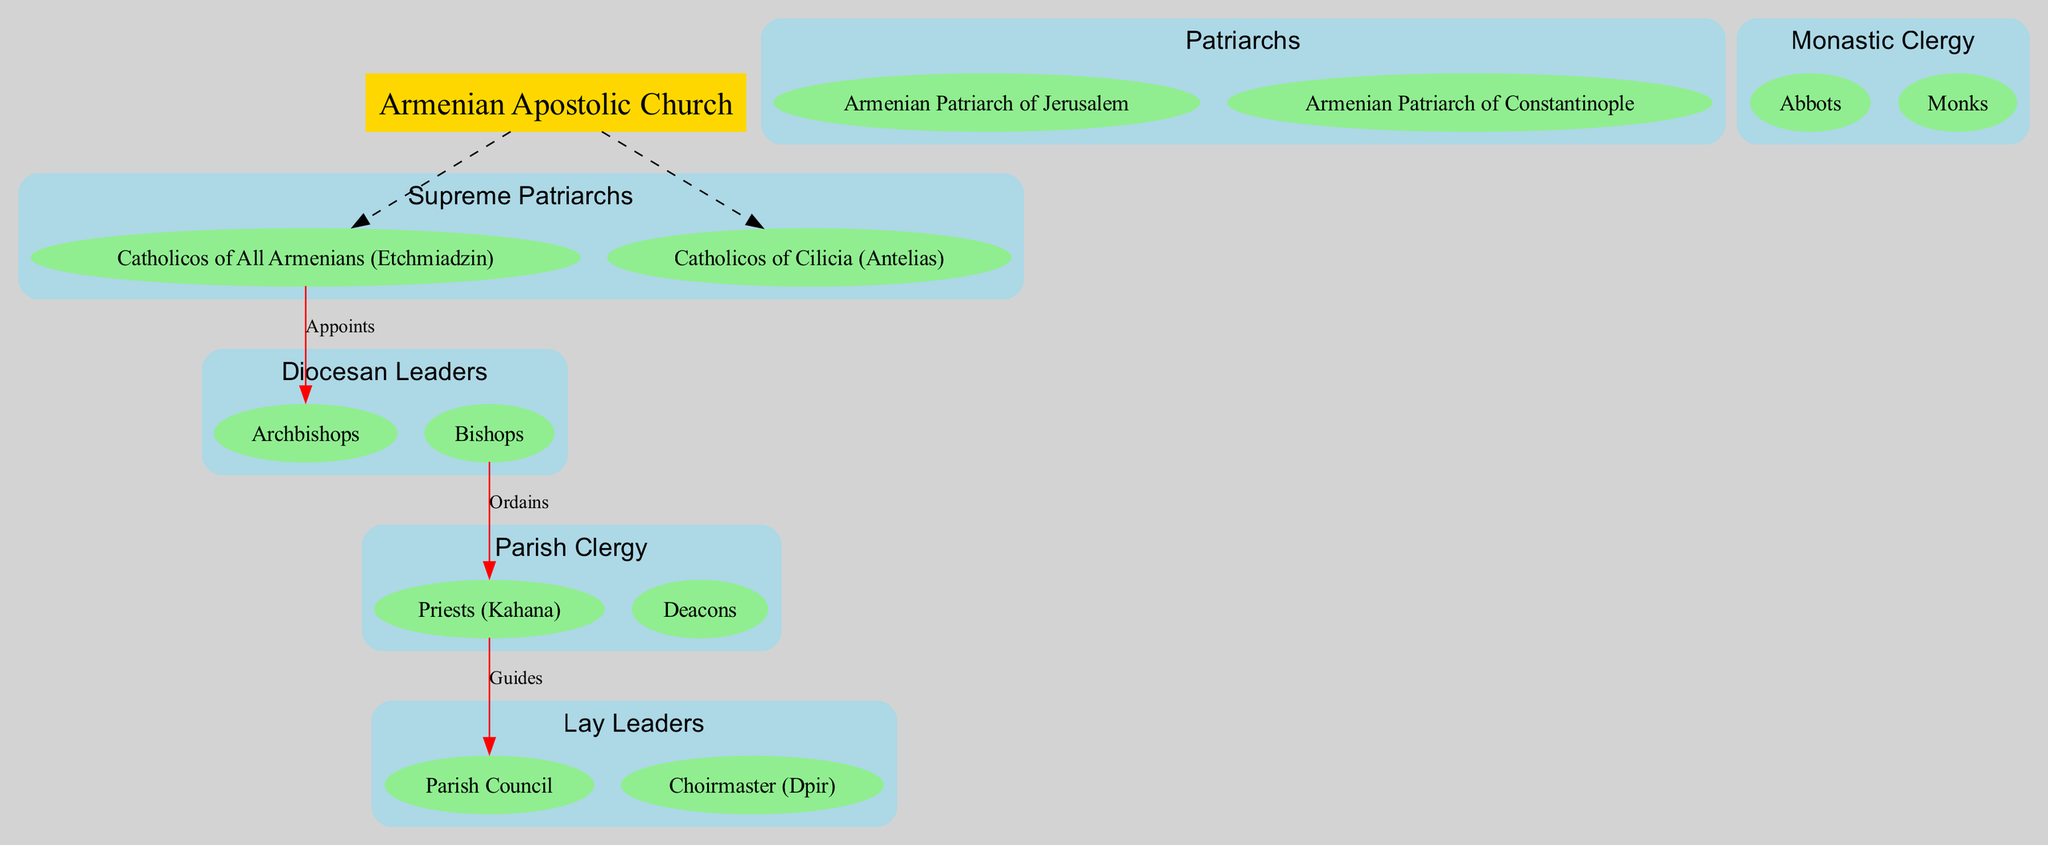What are the two Supreme Patriarchs of the Armenian Apostolic Church? The diagram lists two Supreme Patriarchs, which are the Catholicos of All Armenians (Etchmiadzin) and the Catholicos of Cilicia (Antelias).
Answer: Catholicos of All Armenians (Etchmiadzin), Catholicos of Cilicia (Antelias) How many levels are there in the hierarchical structure? By examining the levels shown in the diagram, there are six distinct levels: Supreme Patriarchs, Patriarchs, Diocesan Leaders, Monastic Clergy, Parish Clergy, and Lay Leaders.
Answer: 6 Who appoints the Archbishops? The diagram indicates that the Catholicos of All Armenians (Etchmiadzin) is responsible for appointing the Archbishops, as shown by the arrow labeled "Appoints" connecting these two nodes.
Answer: Catholicos of All Armenians (Etchmiadzin) What role do Bishops play concerning Priests (Kahana)? The connection between Bishops and Priests (Kahana) is labeled "Ordains," indicating that Bishops have the responsibility to ordain them within the hierarchy.
Answer: Ordains Which roles fall under the category of Parish Clergy? The diagram specifies that the roles under Parish Clergy include Priests (Kahana) and Deacons, as listed in the appropriate section of the hierarchical structure.
Answer: Priests (Kahana), Deacons What is the connection labeled that describes the relationship between Priests (Kahana) and the Parish Council? The diagram connects Priests (Kahana) to the Parish Council with the label "Guides," which indicates that Priests provide guidance to the Parish Council as part of their role.
Answer: Guides Which two categories of leaders are at the same hierarchical level? The diagram shows that Monastic Clergy (composed of Abbots and Monks) and Parish Clergy (composed of Priests and Deacons) maintain parallel positions in the overall hierarchy; they are both fourth in the hierarchy.
Answer: Monastic Clergy, Parish Clergy What is the total number of elements in the Diocesan Leaders level? In the diagram, the Diocesan Leaders level includes Archbishops and Bishops, making a total of two elements in this category.
Answer: 2 